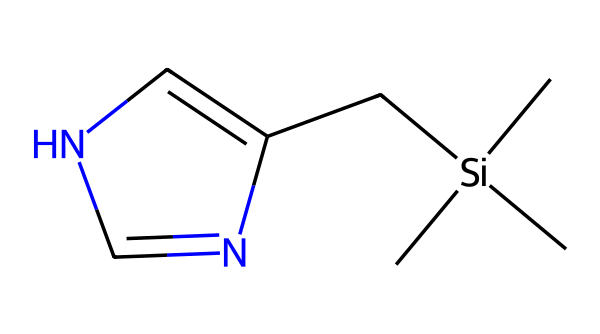How many carbon atoms are present in this compound? By analyzing the SMILES representation, there are C characters present in the sequence that indicate carbon atoms. Counting these C characters gives a total of six carbon atoms in the structure.
Answer: six What is the total number of nitrogen atoms in the chemical structure? The SMILES notation includes the 'N' character, which represents nitrogen atoms. There is one 'N' in the sequence, indicating there is one nitrogen atom in the compound.
Answer: one Which chemical group is indicated by the '[Si]' notation? The '[Si]' notation signifies the presence of a silicon atom in the structure, indicating that this compound is an organosilicon compound due to the incorporation of silicon into the molecular framework.
Answer: silicon What type of bonding is primarily present in this compound? The structure shows multiple carbon-carbon (C-C) and carbon-silicon (C-Si) single bonds, as well as a double bond found in the nitrogen-containing ring, indicating a covalent bonding nature throughout.
Answer: covalent How many total atoms are in the entire chemical structure based on the SMILES? By counting all symbols in the SMILES that represent atoms, including carbon, nitrogen, and silicon, the total count adds up to nine atoms: six carbon, one nitrogen, and one silicon atom.
Answer: nine What main functional group can be deduced from the presence of the nitrogen atom? The nitrogen in the structure suggests the presence of an amine functional group, which is typically associated with properties relevant to growth regulation in tree growth regulators.
Answer: amine What property does the presence of silicon impart to growth regulators? Silicon in organosilicon compounds generally enhances stress tolerance and improves physiological functions in plants, which can be advantageous for conservation purposes in forestry management.
Answer: stress tolerance 